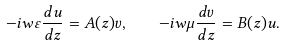<formula> <loc_0><loc_0><loc_500><loc_500>- i w \varepsilon \frac { d u } { d z } = A ( z ) v , \quad - i w \mu \frac { d v } { d z } = B ( z ) u .</formula> 